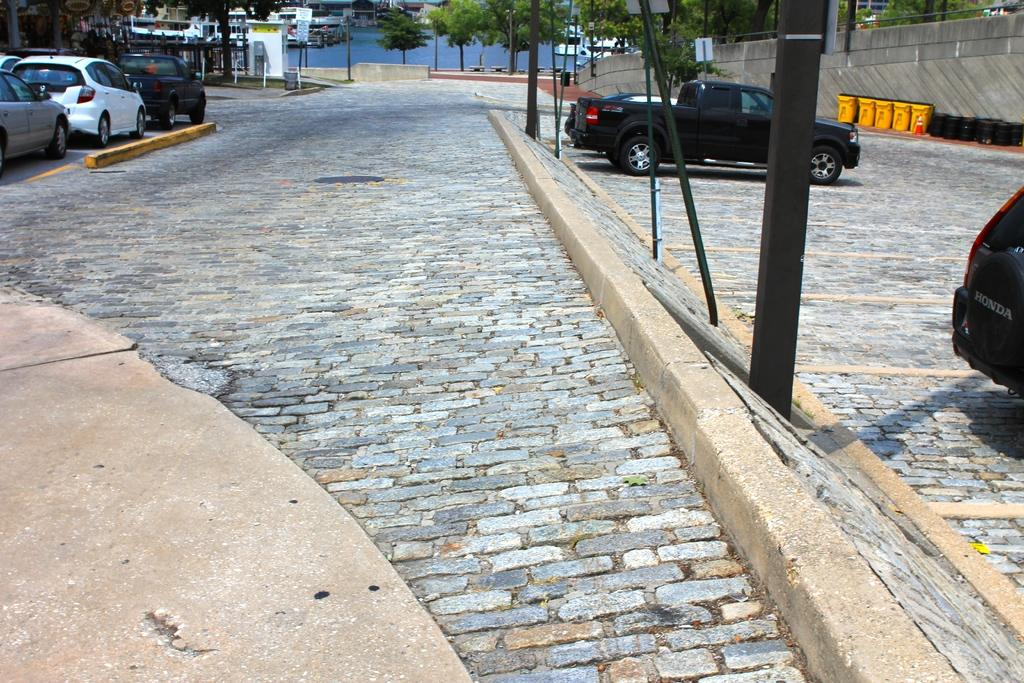What type of path is visible in the image? There is a stoneway in the image. What is happening on the stoneway? Vehicles are present on the stoneway. What can be seen in the distance from the stoneway? Trees are visible in the distance. What objects are present for waste disposal in the image? Trash cans are present in the image. What structures are visible in the image besides the stoneway? Poles are visible in the image. What type of ear is visible on the stoneway in the image? There is no ear present in the image; it features a stoneway, vehicles, trees, trash cans, and poles. 